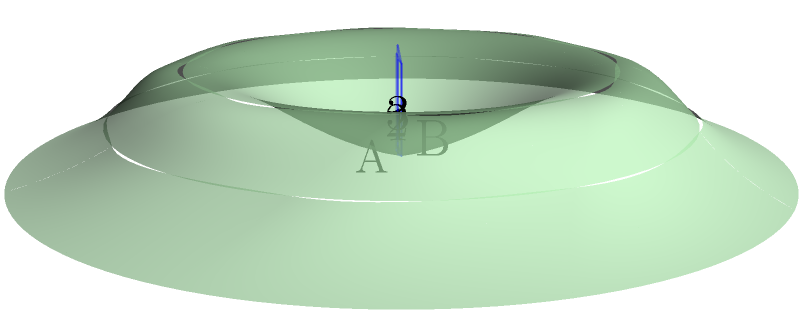A liver-shaped irregular polyhedron is modeled as shown in the figure. Three cross-sectional slices (labeled 1, 2, and 3) are taken perpendicular to the long axis of the liver. If the areas of these cross-sections are 20 cm², 35 cm², and 15 cm² respectively, and the distance between each slice is 2 cm, estimate the volume of the liver using the trapezoidal rule. Round your answer to the nearest cm³. To estimate the volume of the liver-shaped irregular polyhedron using the trapezoidal rule with cross-sectional slices, we'll follow these steps:

1) The trapezoidal rule for volume estimation is given by:
   $$V \approx h(A_1/2 + A_2 + ... + A_{n-1} + A_n/2)$$
   where $h$ is the distance between slices, and $A_i$ are the areas of the cross-sections.

2) We have:
   - Distance between slices, $h = 2$ cm
   - Area of slice 1, $A_1 = 20$ cm²
   - Area of slice 2, $A_2 = 35$ cm²
   - Area of slice 3, $A_3 = 15$ cm²

3) Applying the formula:
   $$V \approx 2((20/2) + 35 + (15/2))$$

4) Simplify:
   $$V \approx 2(10 + 35 + 7.5)$$
   $$V \approx 2(52.5)$$
   $$V \approx 105$$ cm³

5) Rounding to the nearest cm³:
   $$V \approx 105$$ cm³

Therefore, the estimated volume of the liver-shaped polyhedron is approximately 105 cm³.
Answer: 105 cm³ 